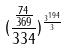<formula> <loc_0><loc_0><loc_500><loc_500>( \frac { \frac { 7 4 } { 3 6 9 } } { 3 3 4 } ) ^ { \frac { 3 ^ { 1 9 4 } } { 3 } }</formula> 